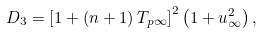Convert formula to latex. <formula><loc_0><loc_0><loc_500><loc_500>D _ { 3 } = \left [ 1 + \left ( n + 1 \right ) T _ { p \infty } \right ] ^ { 2 } \left ( 1 + u _ { \infty } ^ { 2 } \right ) ,</formula> 